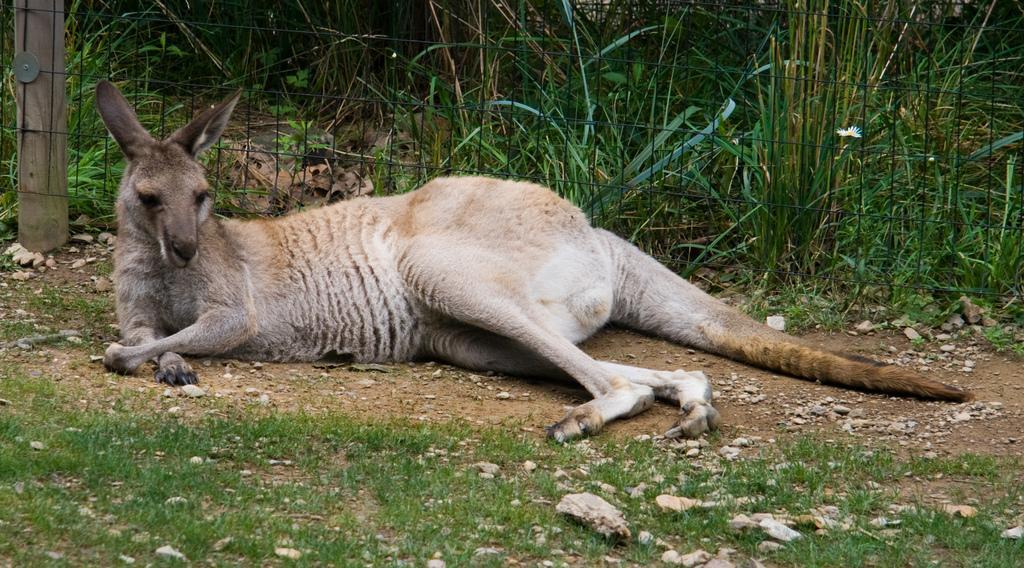Can you describe this image briefly? In this image I can see an animal lying on the ground. An animal is in white, black and brown color. In the back I can see the railing and the plants. 